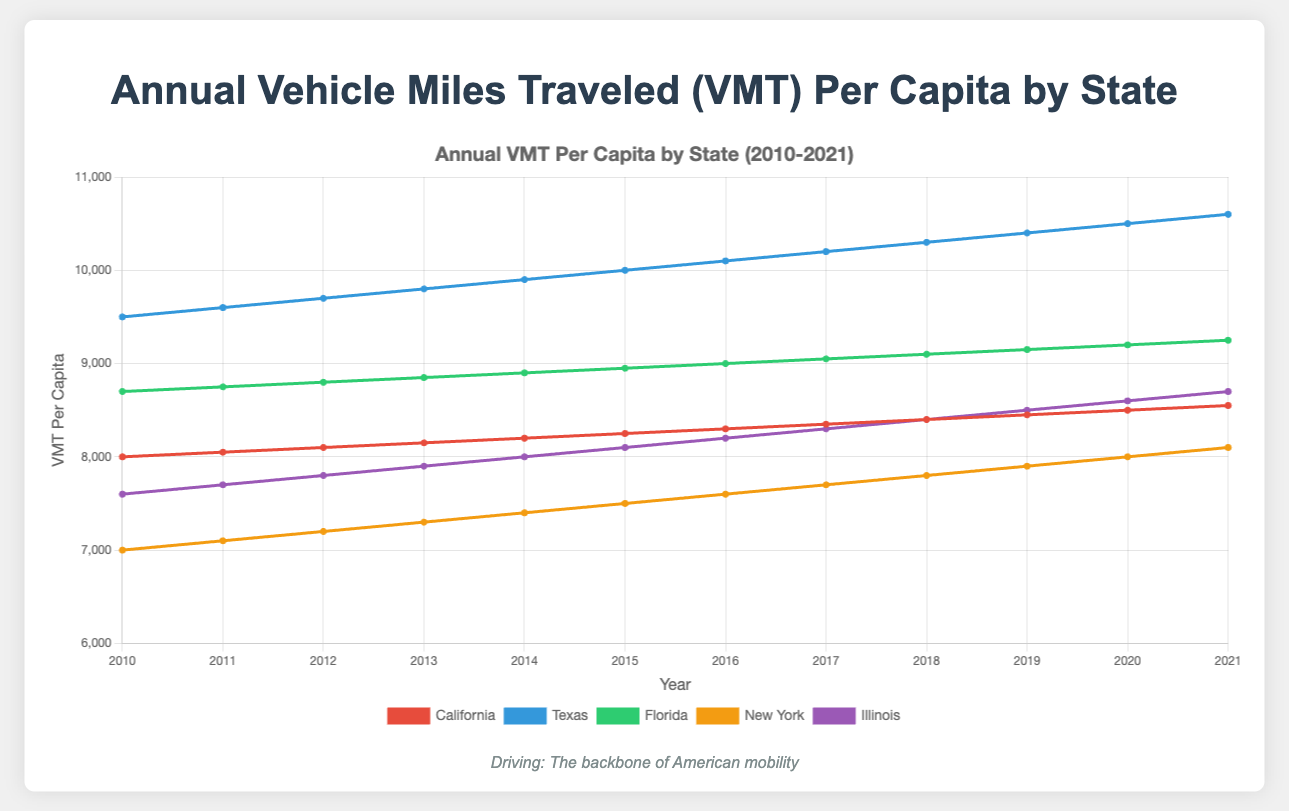Which state had the highest VMT per capita in 2015? By looking at the figure, find the data points for all states in the year 2015. Compare the values: California (8250), Texas (10000), Florida (8950), New York (7500), Illinois (8100). Texas has the highest value.
Answer: Texas Which state saw the largest increase in VMT per capita from 2010 to 2021? Calculate the difference between 2021 and 2010 VMT per capita for each state: California (8550-8000), Texas (10600-9500), Florida (9250-8700), New York (8100-7000), Illinois (8700-7600). Texas shows the largest increase (1100).
Answer: Texas What was the average VMT per capita across all states in 2018? Sum the VMT per capita values for all states in 2018 and divide by the number of states: (8400 + 10300 + 9100 + 7800 + 8400) / 5 = 8920.
Answer: 8920 In which year did Florida first surpass a VMT per capita of 9000? Analyze the trendline for Florida and identify the first year it reaches above 9000. It's in the year 2016 with a value of 9000 exactly.
Answer: 2016 How many states had a higher VMT per capita than Illinois in 2020? Find the VMT per capita for Illinois in 2020 (8600) and compare it with values for the other states in the same year: California (8500), Texas (10500), Florida (9200), New York (8000). Three states (Texas, Florida, California) have higher values.
Answer: 3 Which state had the smallest increase in VMT per capita from 2010 to 2021? Calculate the difference for each state: California (8550-8000), Texas (10600-9500), Florida (9250-8700), New York (8100-7000), Illinois (8700-7600). New York shows the smallest increase (1100).
Answer: New York Between 2010 and 2015, which state had the most consistent growth in VMT per capita? Check the trendlines for each state from 2010 to 2015. California's line is the most linear and consistent, increasing steadily from 8000 to 8250.
Answer: California What is the overall trend for VMT per capita for New York from 2010 to 2021? Observe the trendline for New York from 2010 to 2021. It shows a consistent upward trend from 7000 to 8100.
Answer: Upward Did any state experience a decline in VMT per capita in any year between 2010 and 2021? Observe all the trendlines for sudden drops. No states show a decline in any year; all states show either an increase or remain flat year over year.
Answer: No 